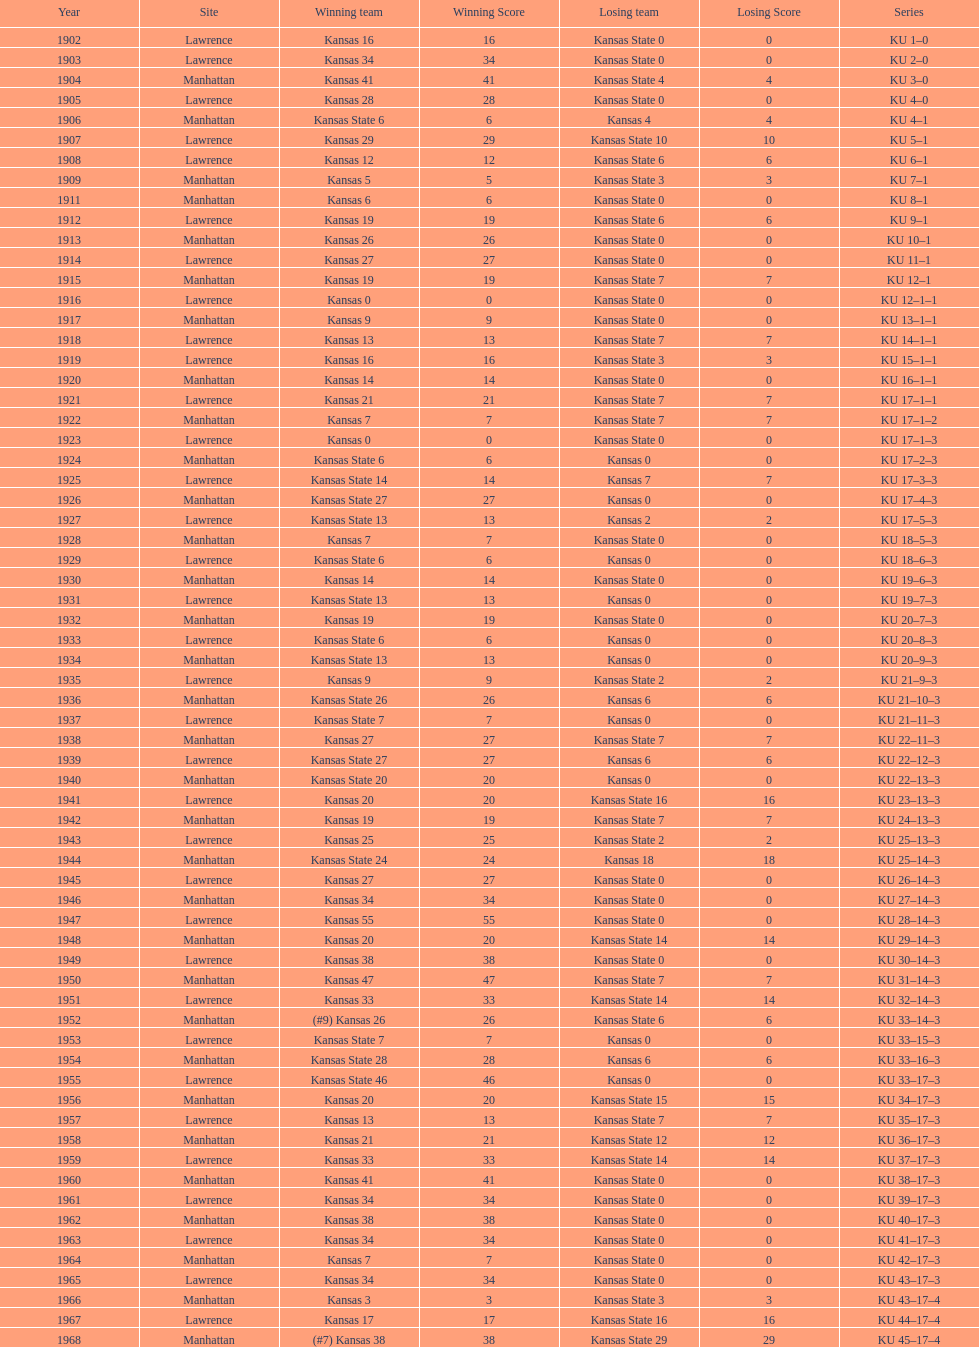Before 1950 what was the most points kansas scored? 55. 